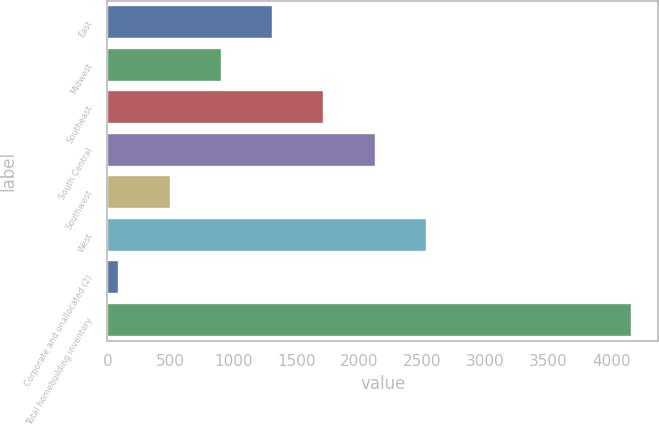<chart> <loc_0><loc_0><loc_500><loc_500><bar_chart><fcel>East<fcel>Midwest<fcel>Southeast<fcel>South Central<fcel>Southwest<fcel>West<fcel>Corporate and unallocated (2)<fcel>Total homebuilding inventory<nl><fcel>1315.57<fcel>908.48<fcel>1722.66<fcel>2129.75<fcel>501.39<fcel>2536.84<fcel>94.3<fcel>4165.2<nl></chart> 